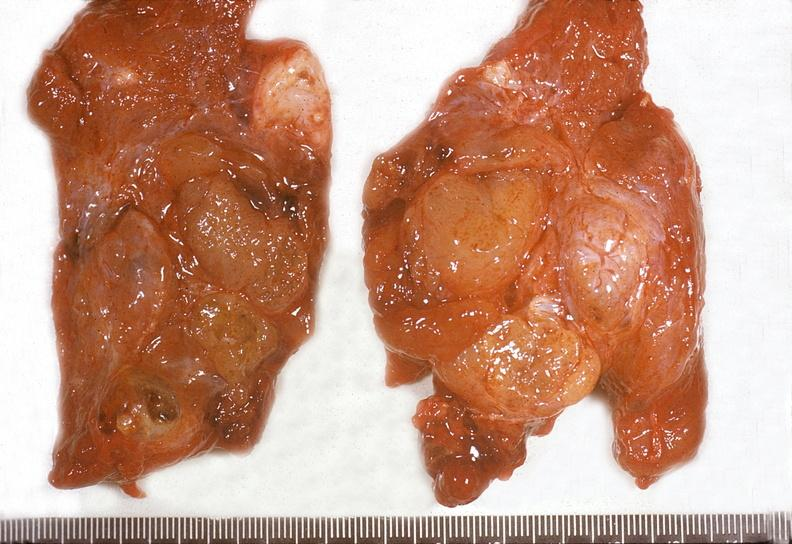where does this belong to?
Answer the question using a single word or phrase. Endocrine system 